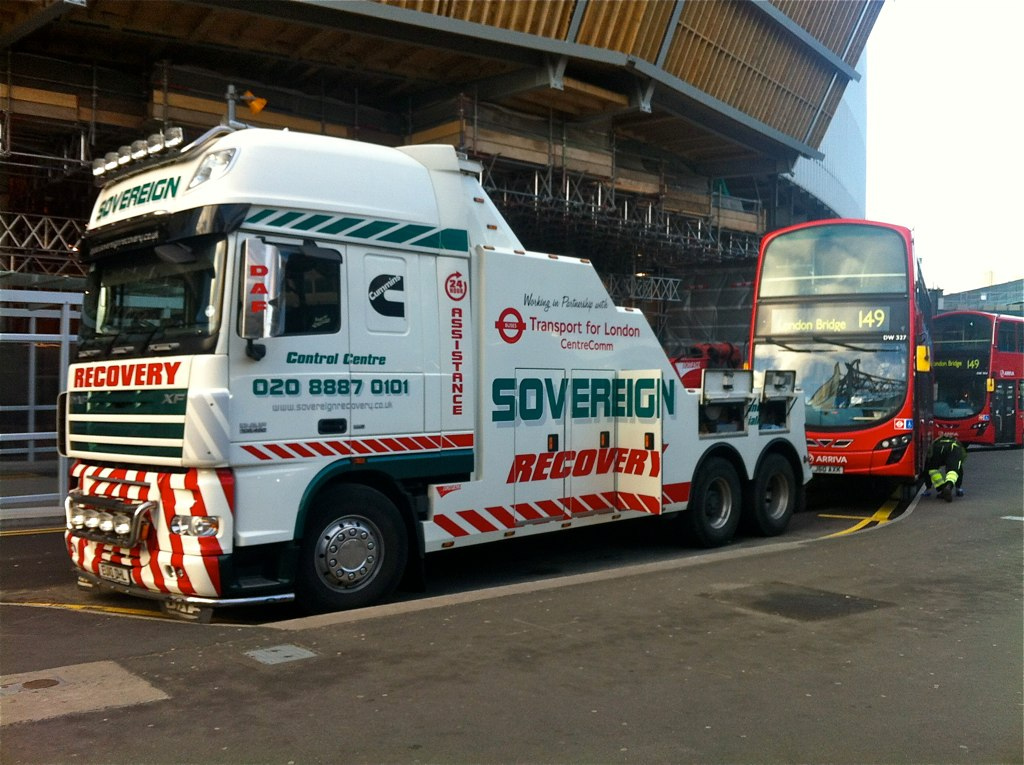How many wheels are shown on the truck? In the visible portion of the truck, there are a total of five wheels observable, with two on the front axle and three on the rear axle. However, given the angle and the standard configuration of such recovery trucks, it's likely that there are more wheels on the other side that are not visible in the image. 